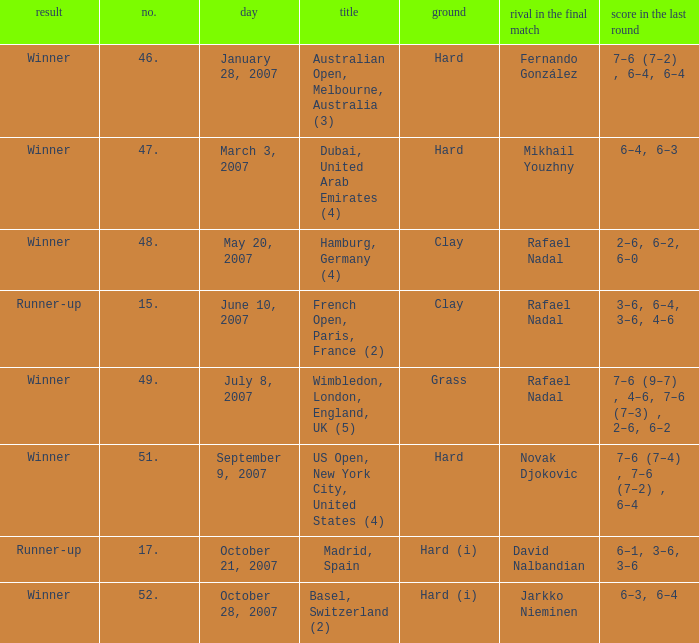The score in the finale is 2-6, 6-2, 6-0, on which surface? Clay. 